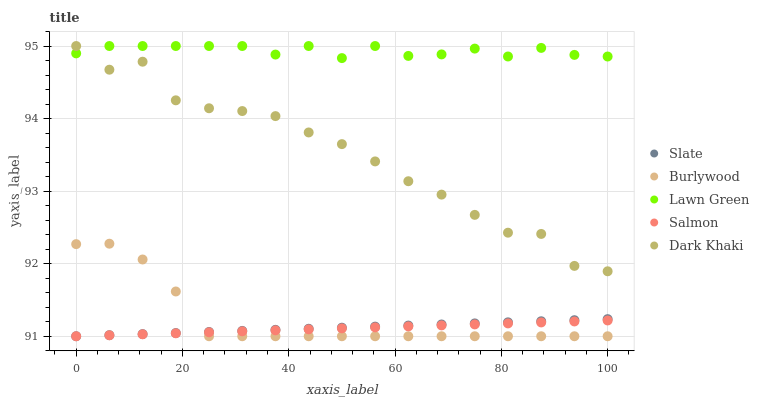Does Salmon have the minimum area under the curve?
Answer yes or no. Yes. Does Lawn Green have the maximum area under the curve?
Answer yes or no. Yes. Does Slate have the minimum area under the curve?
Answer yes or no. No. Does Slate have the maximum area under the curve?
Answer yes or no. No. Is Salmon the smoothest?
Answer yes or no. Yes. Is Dark Khaki the roughest?
Answer yes or no. Yes. Is Lawn Green the smoothest?
Answer yes or no. No. Is Lawn Green the roughest?
Answer yes or no. No. Does Burlywood have the lowest value?
Answer yes or no. Yes. Does Lawn Green have the lowest value?
Answer yes or no. No. Does Dark Khaki have the highest value?
Answer yes or no. Yes. Does Slate have the highest value?
Answer yes or no. No. Is Burlywood less than Lawn Green?
Answer yes or no. Yes. Is Dark Khaki greater than Salmon?
Answer yes or no. Yes. Does Slate intersect Salmon?
Answer yes or no. Yes. Is Slate less than Salmon?
Answer yes or no. No. Is Slate greater than Salmon?
Answer yes or no. No. Does Burlywood intersect Lawn Green?
Answer yes or no. No. 